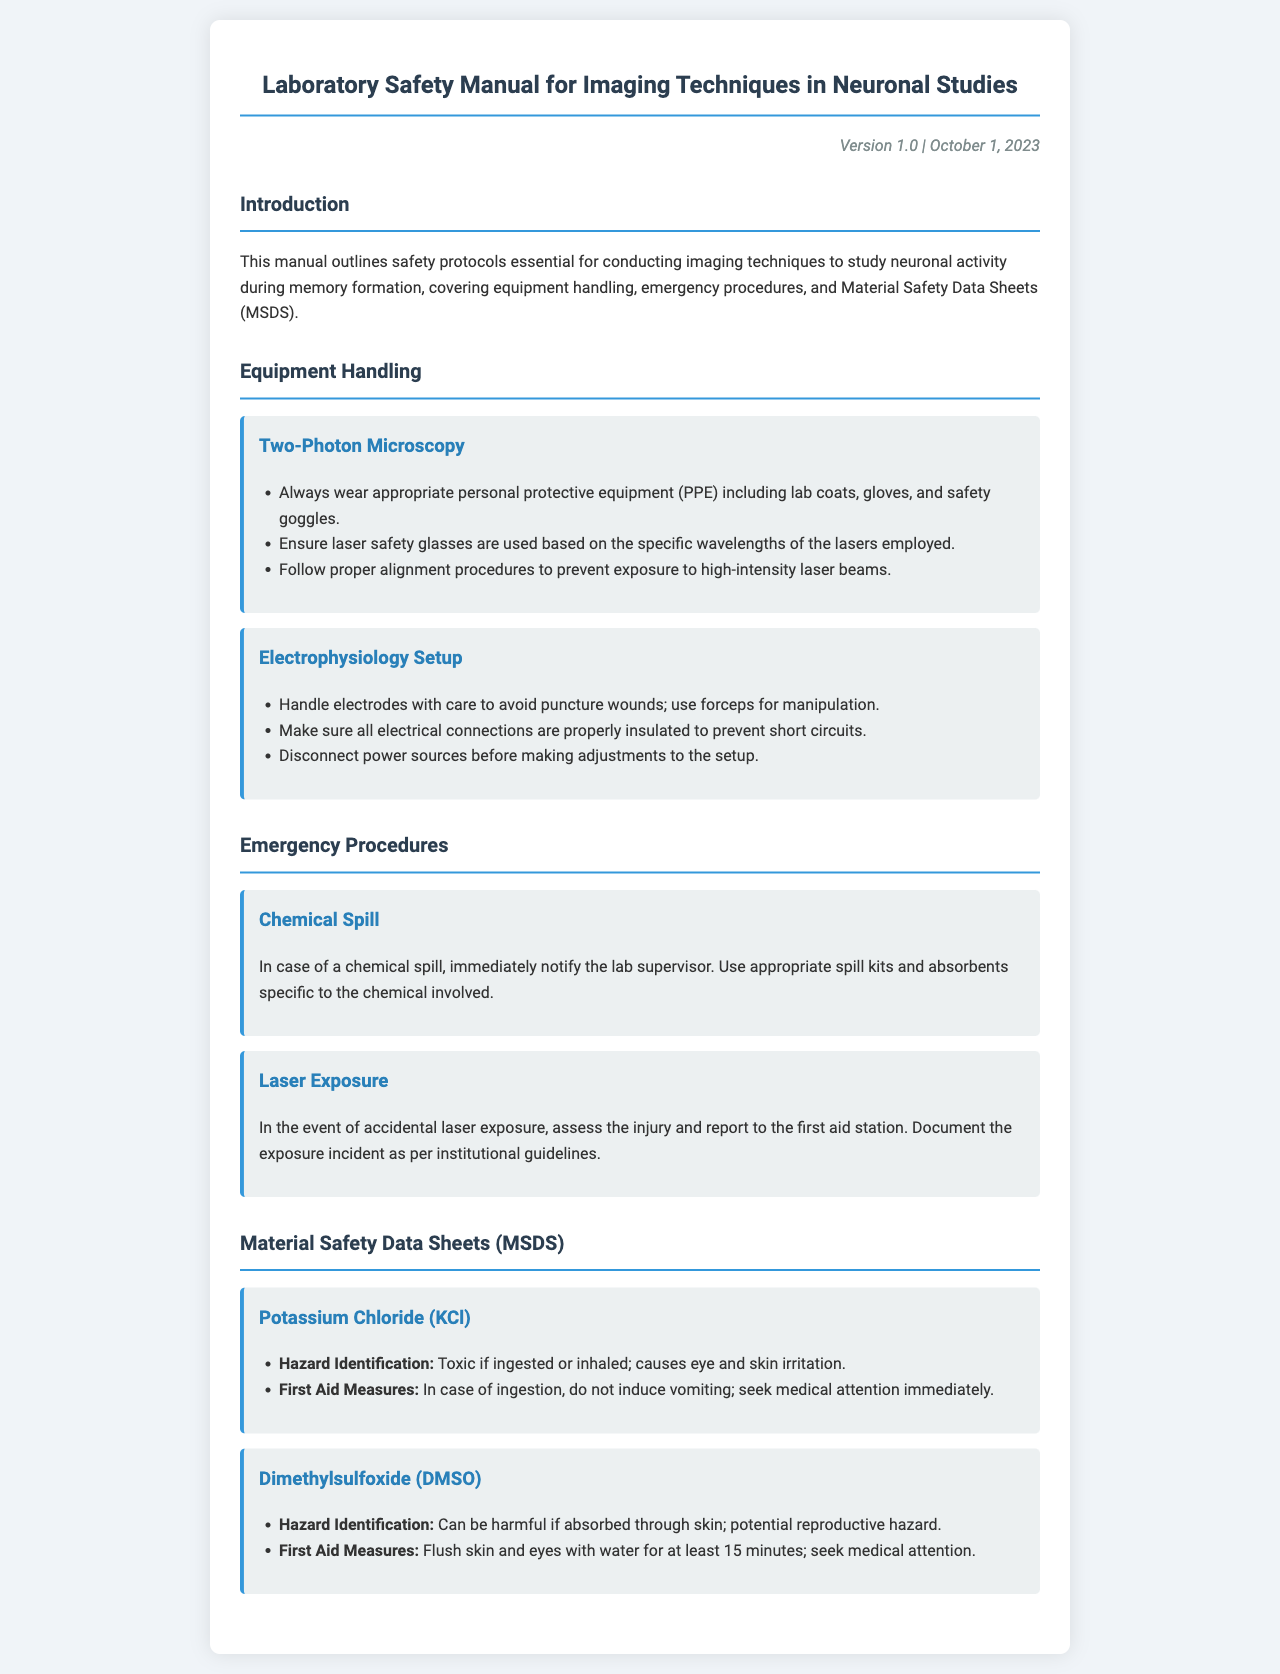What is the version date of the manual? The version date is indicated near the title of the manual as the date of the latest update.
Answer: October 1, 2023 What personal protective equipment is required for Two-Photon Microscopy? The document specifies that personal protective equipment (PPE) must include lab coats, gloves, and safety goggles.
Answer: Lab coats, gloves, and safety goggles What should you do in case of a chemical spill? The procedure for a chemical spill includes notifying the lab supervisor and using appropriate spill kits and absorbents.
Answer: Notify the lab supervisor and use spill kits What type of hazard is associated with Dimethylsulfoxide? The document mentions that Dimethylsulfoxide can be harmful if absorbed through skin and is a potential reproductive hazard.
Answer: Harmful if absorbed through skin; reproductive hazard What is the first aid measure for potassium chloride ingestion? The manual states that the first aid measure is to not induce vomiting and seek medical attention immediately.
Answer: Do not induce vomiting; seek medical attention What are the proper alignment procedures aimed to prevent in Two-Photon Microscopy? Proper alignment procedures are aimed to prevent exposure to high-intensity laser beams.
Answer: Exposure to high-intensity laser beams What should be done before adjusting the electrophysiology setup? It is important to disconnect power sources before making any adjustments to ensure safety.
Answer: Disconnect power sources What should be done in case of accidental laser exposure? The response in case of accidental laser exposure includes assessing the injury, reporting to the first aid station, and documenting the incident.
Answer: Assess injury, report to first aid, document incident 